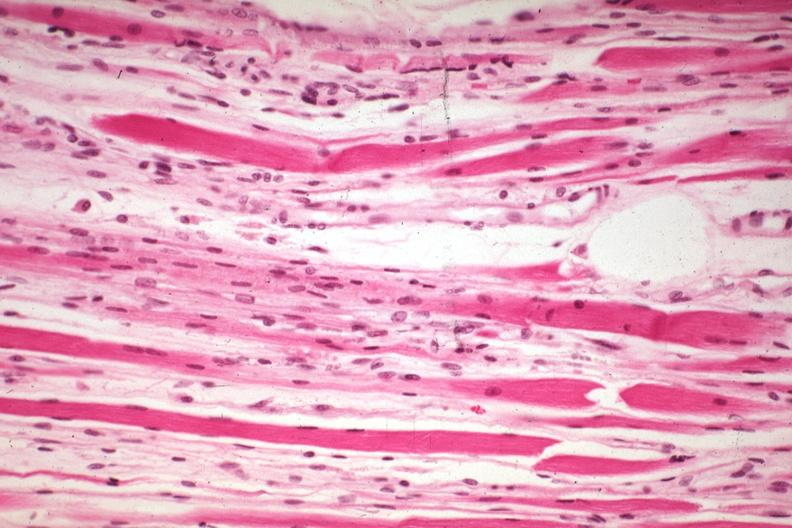what is present?
Answer the question using a single word or phrase. Soft tissue 